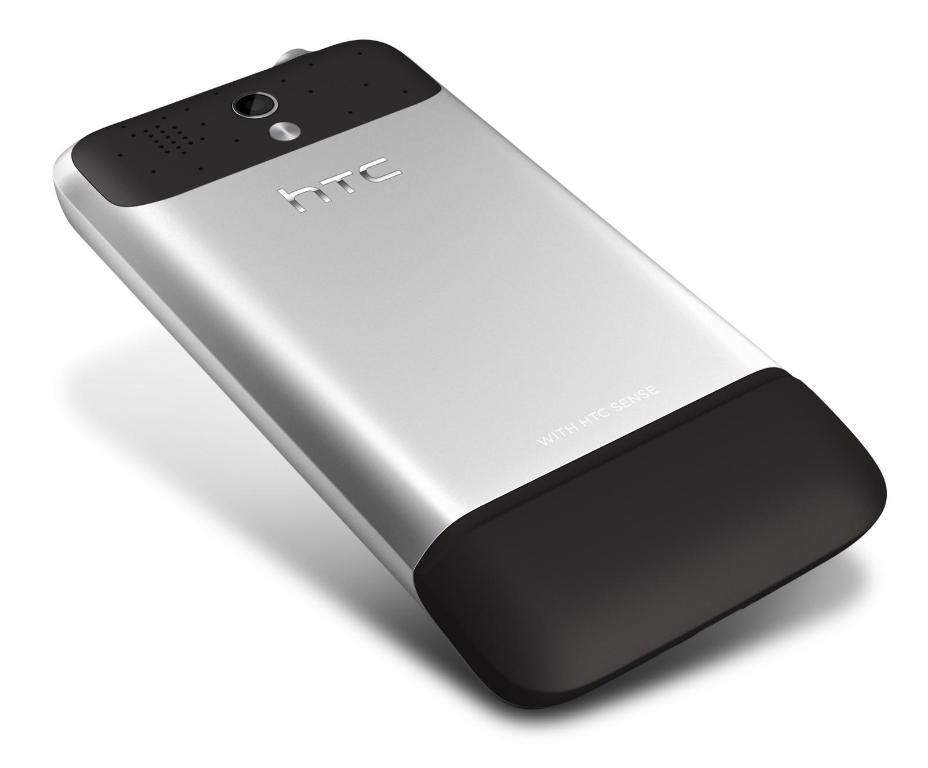What type of mobile phone is visible in the image? There is an HTC mobile phone in the picture. What color is the background of the image? The background of the image is white. What type of attraction can be seen in the background of the image? There is no attraction visible in the image, as the background is white. Is there a bathtub in the image? There is no bathtub present in the image. 